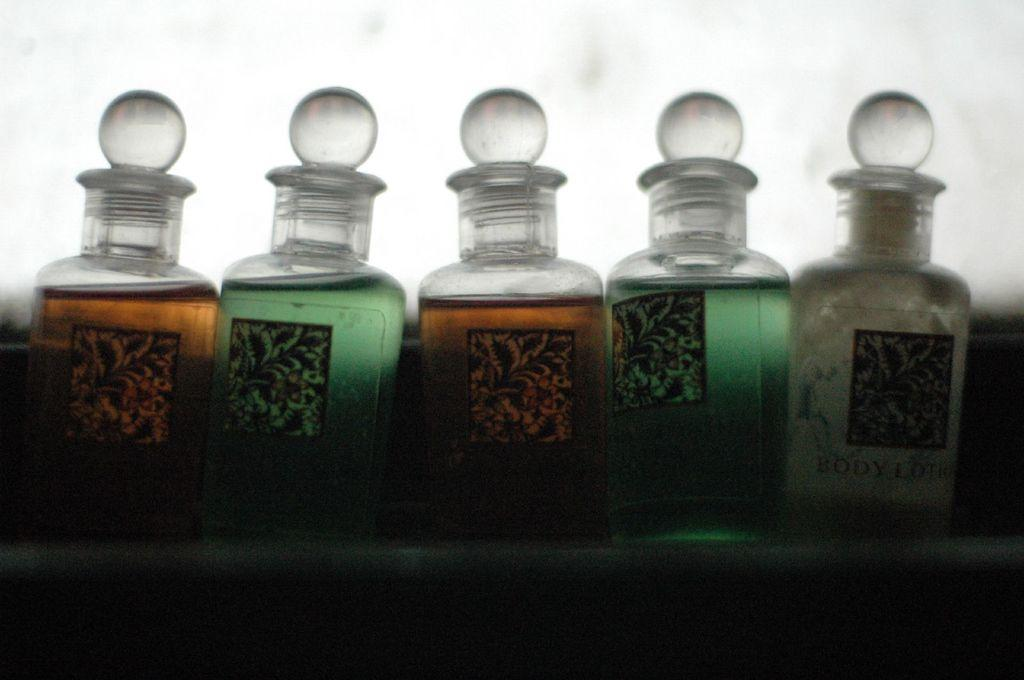Provide a one-sentence caption for the provided image. Five bottled items sit in a row, the right one of which is body lotion. 